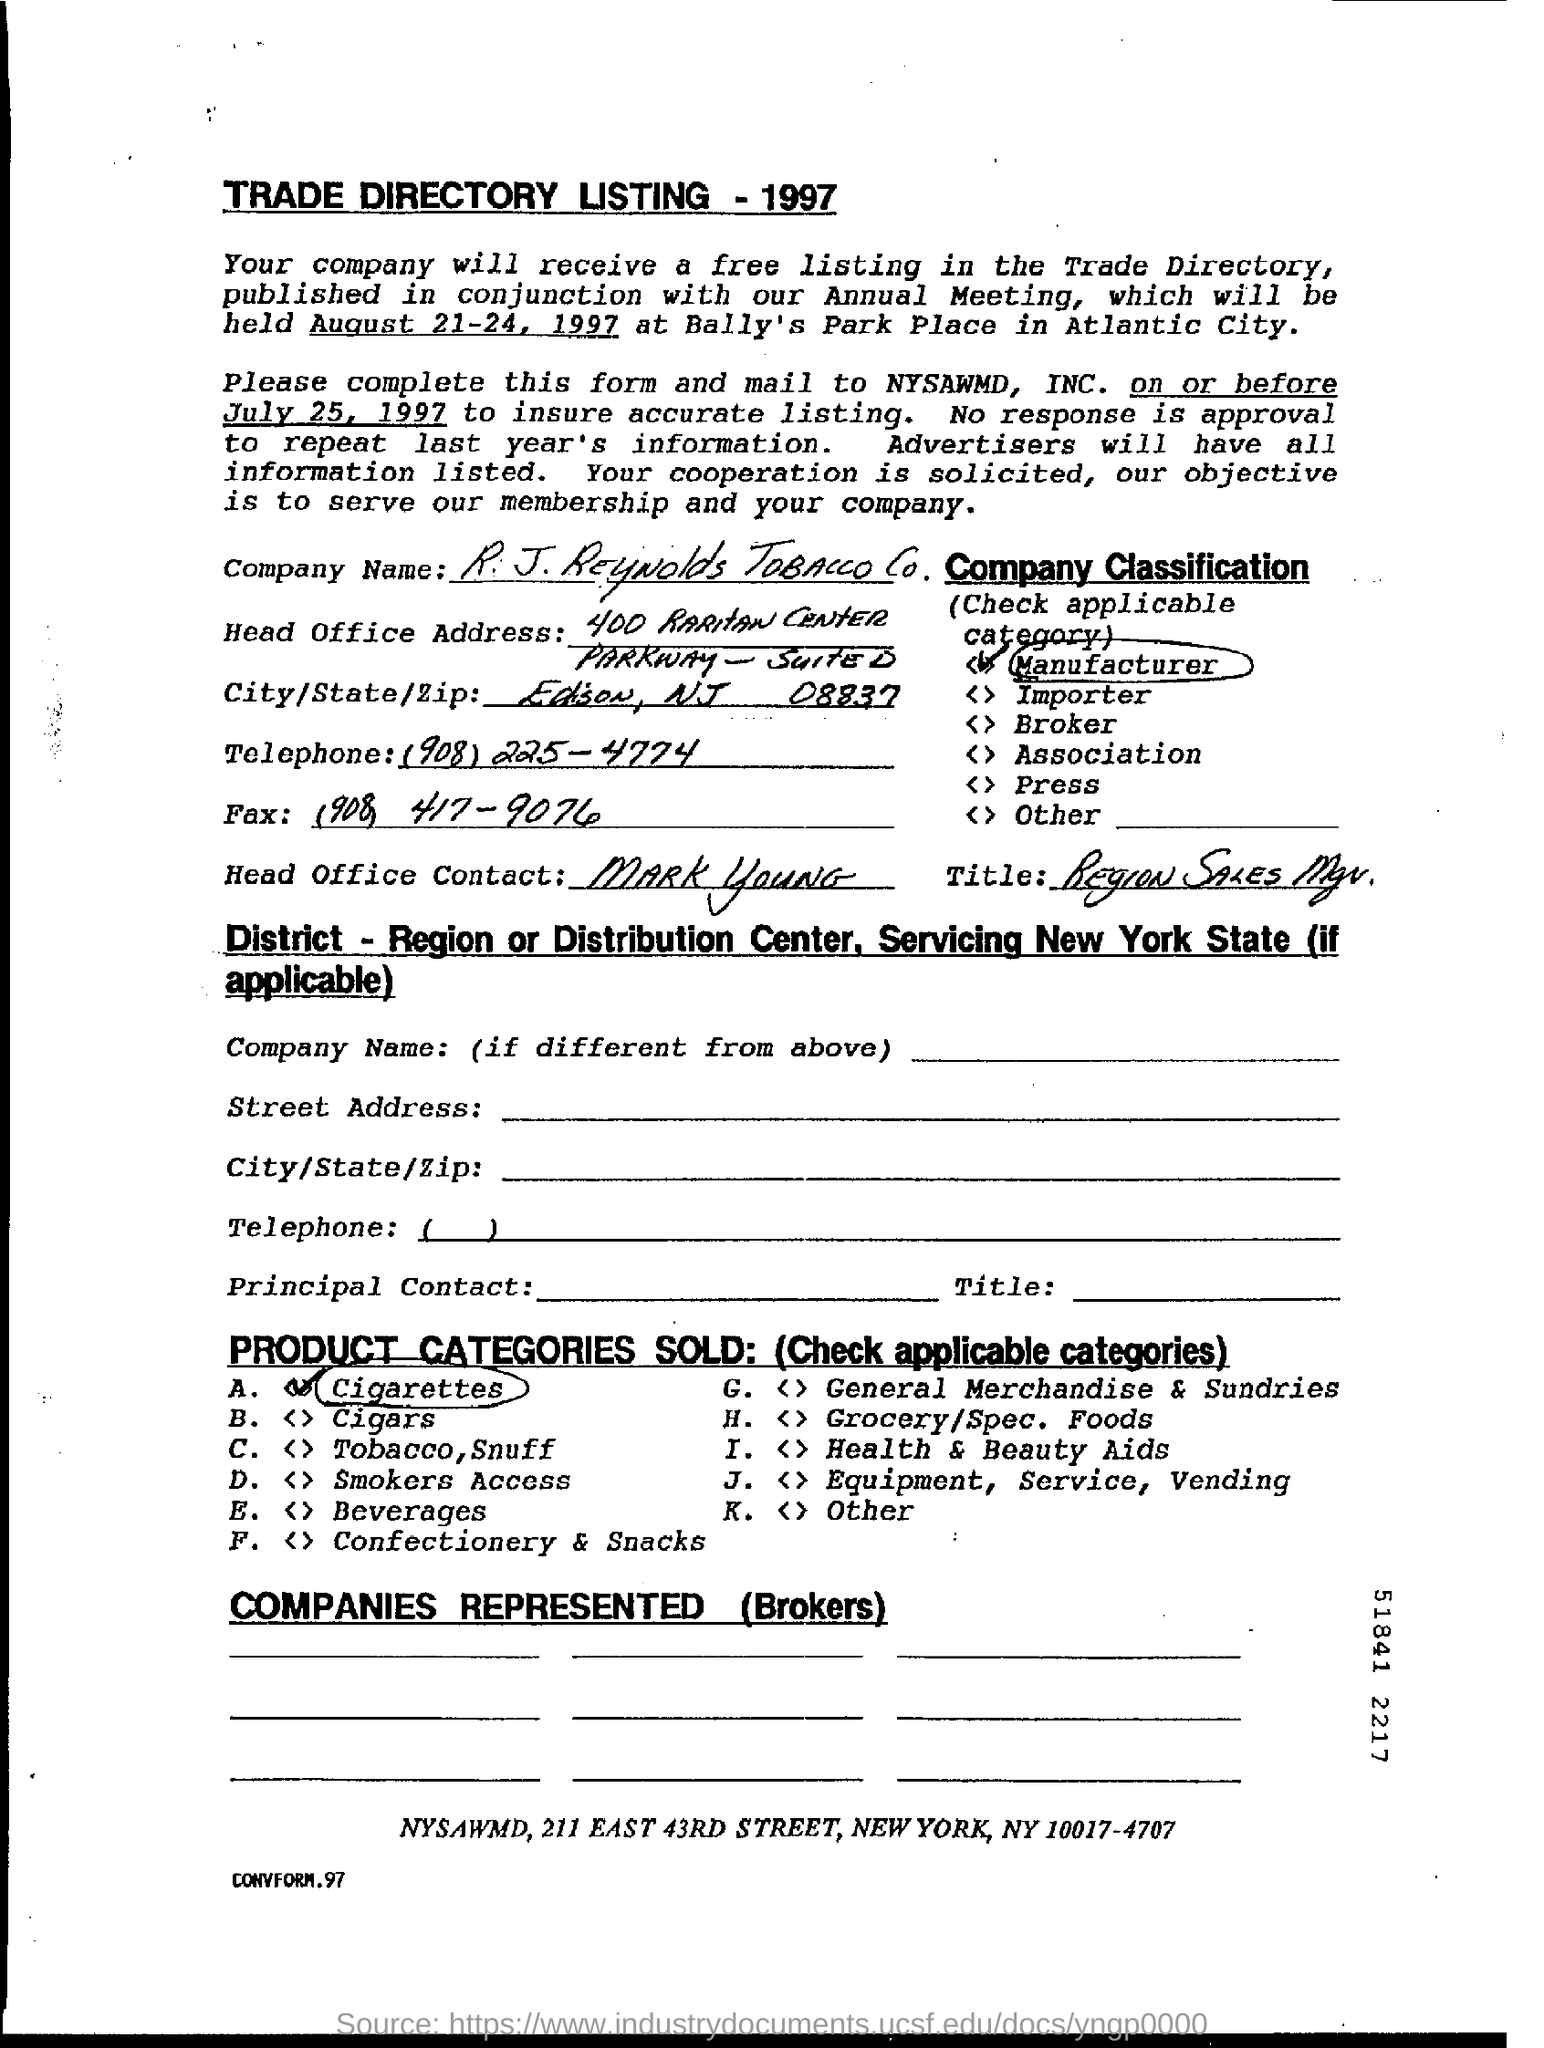List a handful of essential elements in this visual. The Head Office Contact is Mark Young. What is the "Title"? Region Sales Mgr... The fact that the fax number has been filled in the form is (908) 417-9076. The telephone is a communication device that is used to transmit and receive voice signals over a distance. The number "908 225-4774" is associated with the telephone and is used to identify and contact it. The company name is R.J. Reynolds Tobacco Company. 